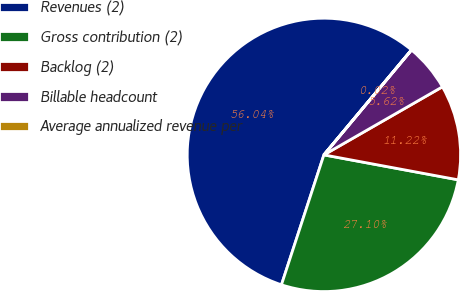<chart> <loc_0><loc_0><loc_500><loc_500><pie_chart><fcel>Revenues (2)<fcel>Gross contribution (2)<fcel>Backlog (2)<fcel>Billable headcount<fcel>Average annualized revenue per<nl><fcel>56.03%<fcel>27.1%<fcel>11.22%<fcel>5.62%<fcel>0.02%<nl></chart> 